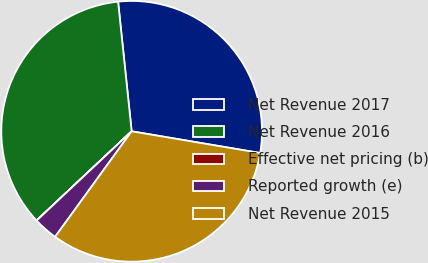<chart> <loc_0><loc_0><loc_500><loc_500><pie_chart><fcel>Net Revenue 2017<fcel>Net Revenue 2016<fcel>Effective net pricing (b)<fcel>Reported growth (e)<fcel>Net Revenue 2015<nl><fcel>29.32%<fcel>35.33%<fcel>0.01%<fcel>3.01%<fcel>32.32%<nl></chart> 